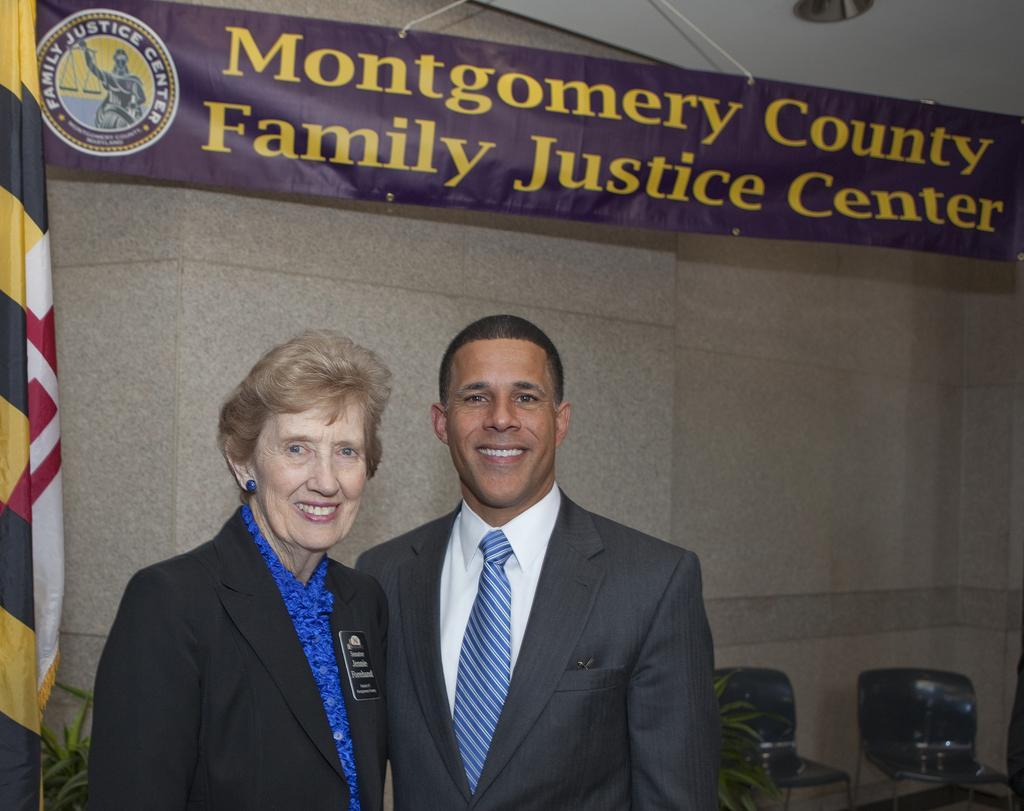Please provide a concise description of this image. In this picture we can see there are two people are standing, and behind the people there are house plants, chairs, wall and a banner. 